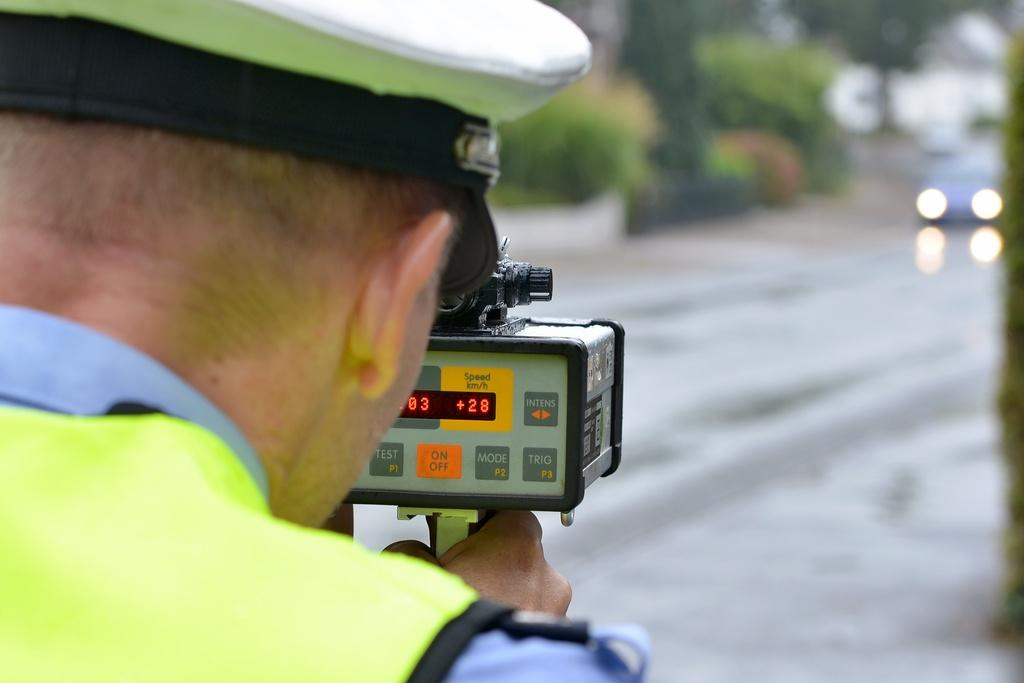What is the person in the image wearing on their head? The person in the image is wearing a cap. What is the person holding in the image? The person is holding an object. What can be seen in front of the person in the image? There is a vehicle in front of the person. What type of natural scenery is visible in the image? Trees are visible in the image. What type of drain can be seen in the image? There is no drain present in the image. What subject is the person teaching in the image? The image does not depict any teaching or educational activity. 